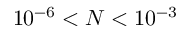<formula> <loc_0><loc_0><loc_500><loc_500>1 0 ^ { - 6 } < N < 1 0 ^ { - 3 }</formula> 